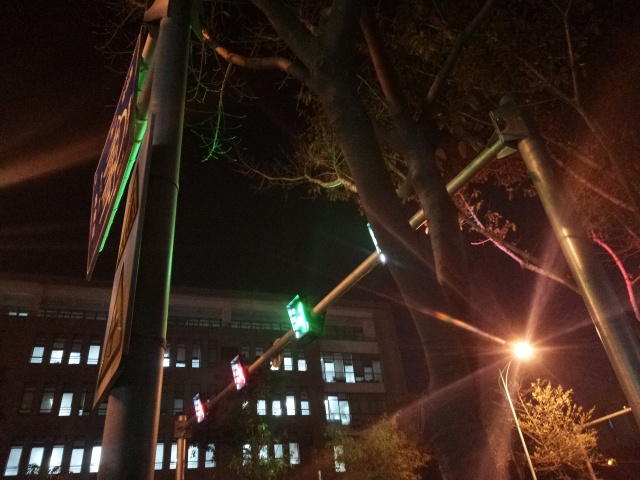Can you describe any signs or symbols visible in the image, and what they might indicate? Visible in the image is a traffic light showing a red stop signal alongside a green left arrow, indicating that vehicles must stop unless turning left. This pairing of lights is a common traffic control system designed to safely manage vehicular movement through intersections. 